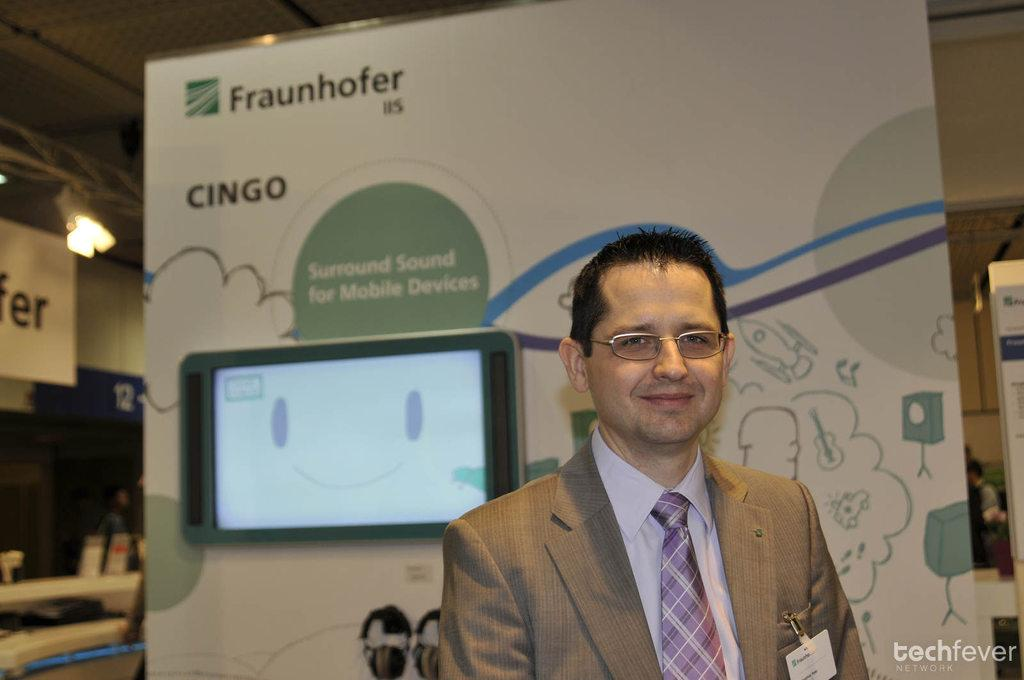Who is present in the image? There is a man in the image. What is the man wearing? The man is wearing clothes and spectacles. What is the man's facial expression? The man is smiling. What objects can be seen in the image besides the man? There is a screen and a poster in the image. What can be observed about the lighting in the image? There is light visible in the image. Is there any additional information about the image itself? There is a watermark in the bottom right corner of the image. What song is the man's daughter singing in the image? There is no mention of a daughter or any singing in the image. 